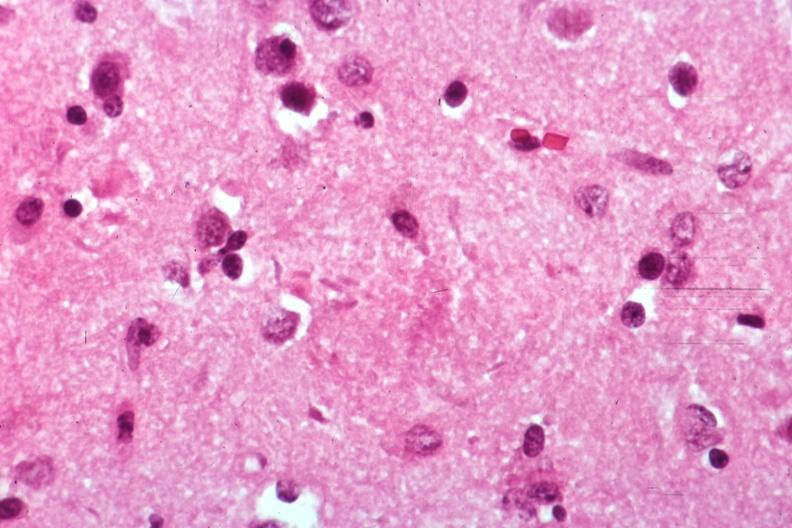what is present?
Answer the question using a single word or phrase. Alzheimers 